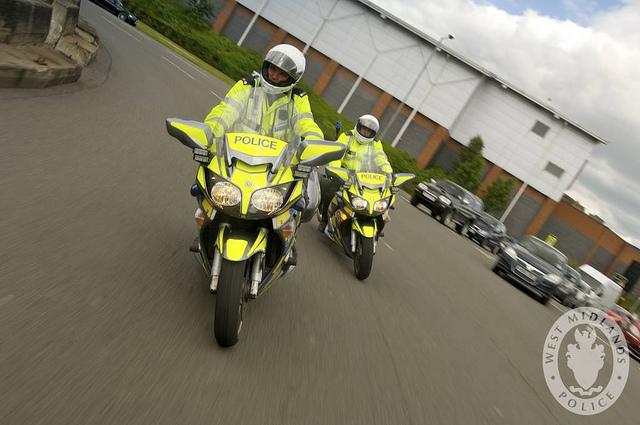Is there any moving motorcycle that only has one person on it?
Write a very short answer. Yes. What do the people have on their heads?
Short answer required. Helmets. What color is their uniform?
Write a very short answer. Yellow. How many wheels does the yellow bike have?
Be succinct. 2. Who are riding these motorcycles?
Write a very short answer. Police. 